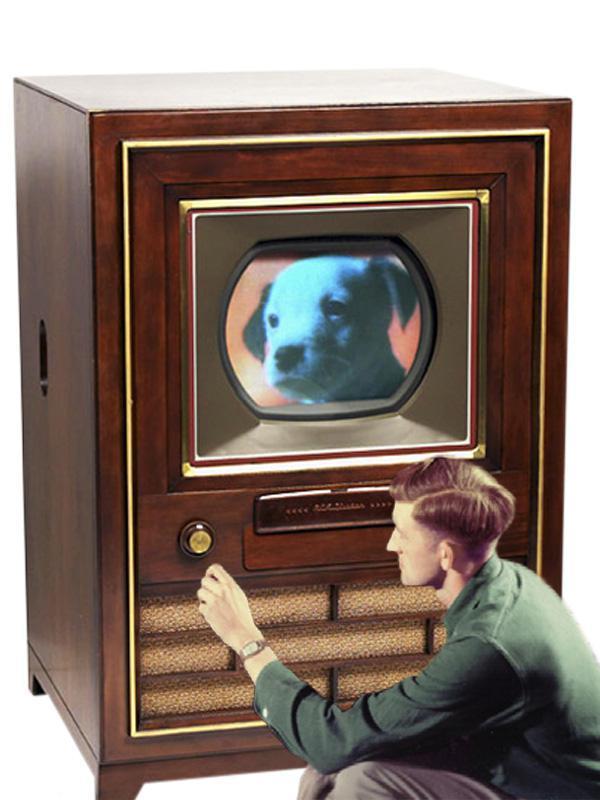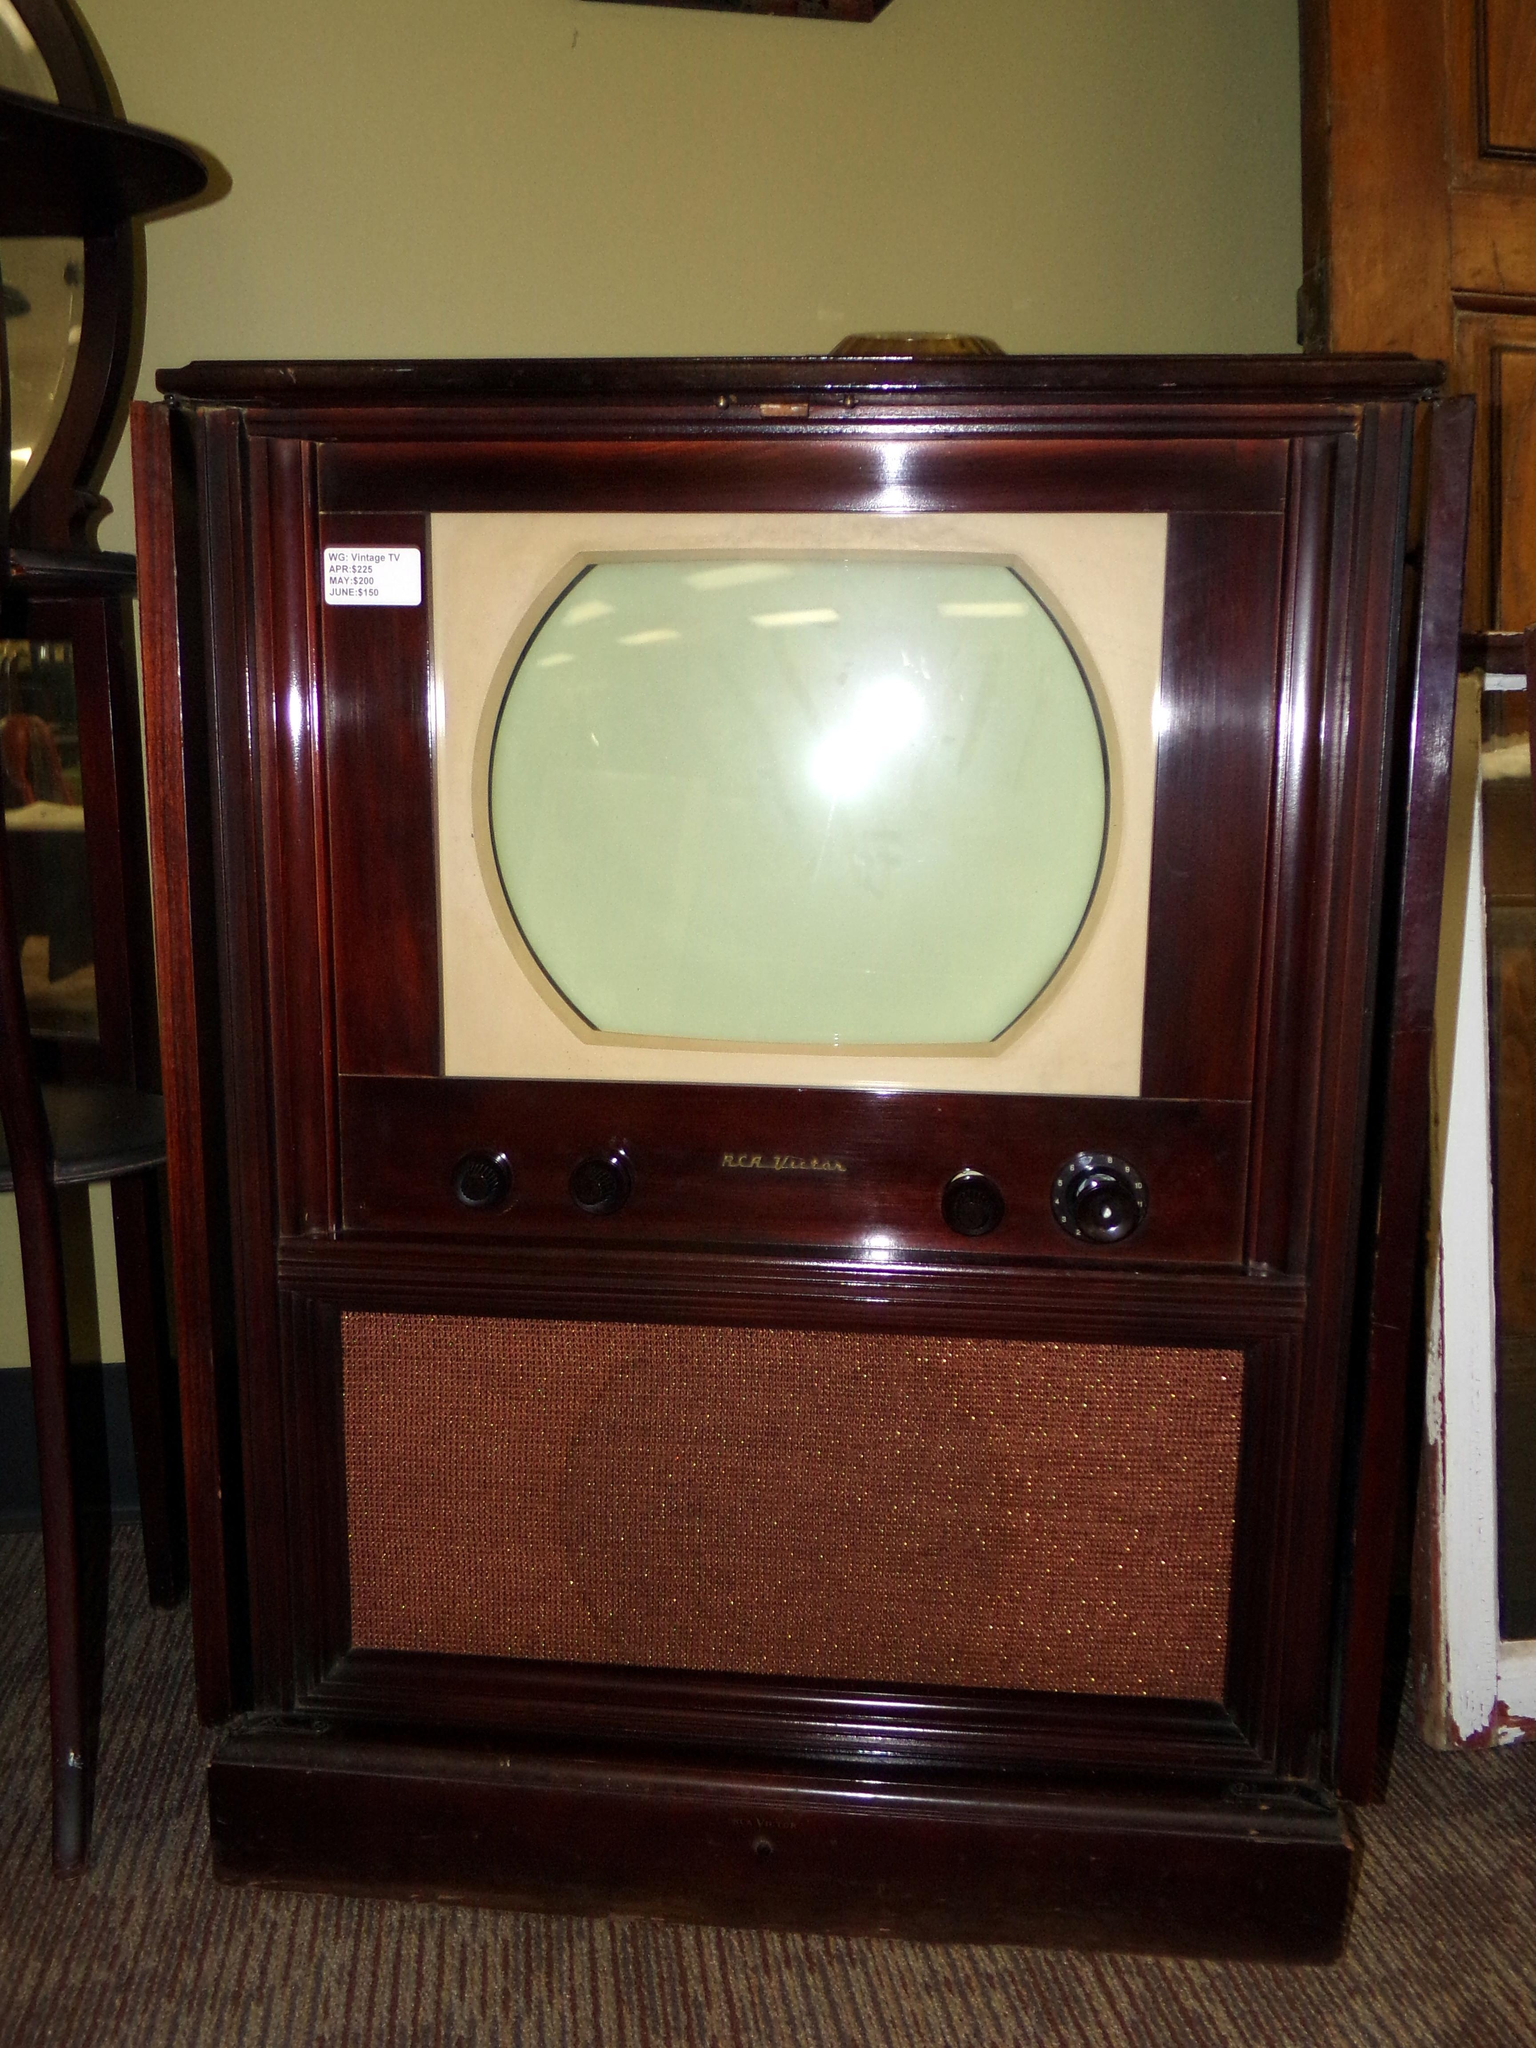The first image is the image on the left, the second image is the image on the right. Assess this claim about the two images: "Two console televison cabinets in dark wood feature a picture tube in the upper section and speakers housed in the bottom section.". Correct or not? Answer yes or no. Yes. The first image is the image on the left, the second image is the image on the right. For the images displayed, is the sentence "Both TVs feature small non-square screens set in boxy wood consoles, and one has a picture playing on its screen, while the other has a rich cherry finish console." factually correct? Answer yes or no. Yes. 